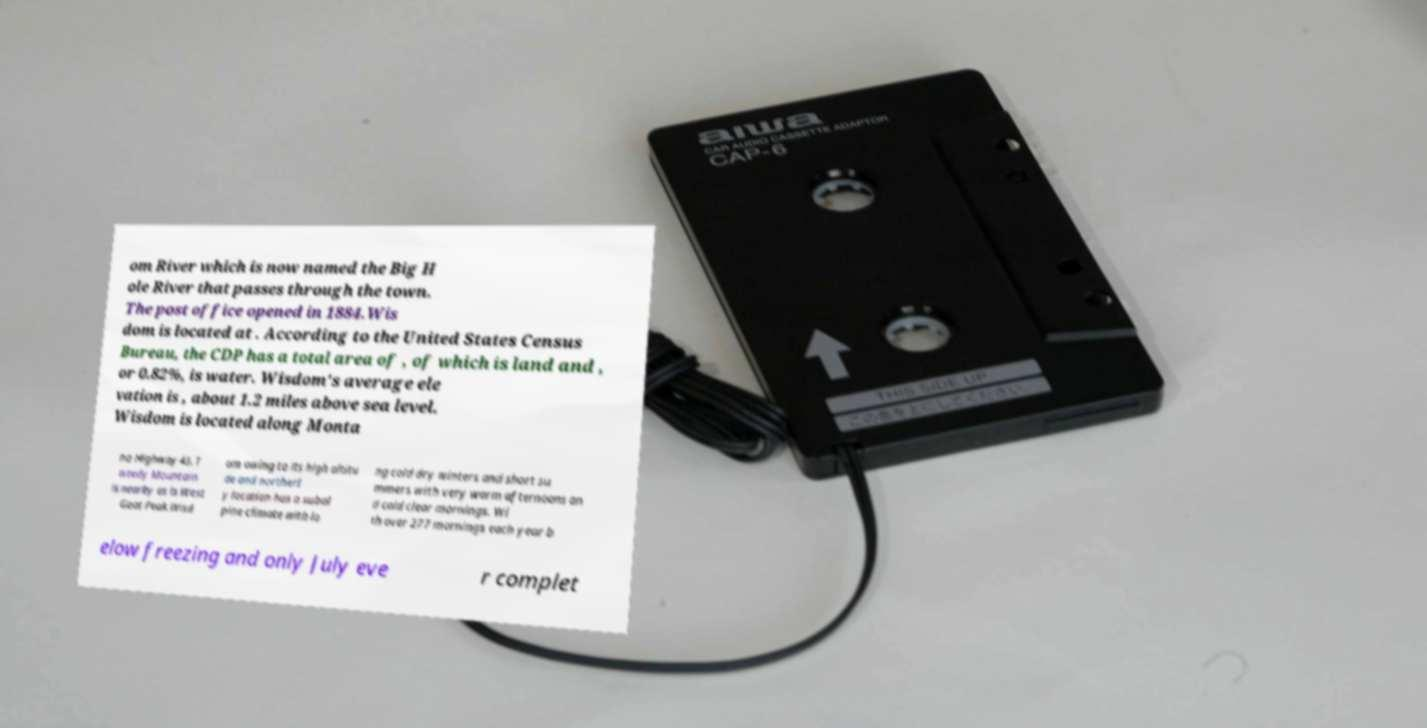Could you extract and type out the text from this image? om River which is now named the Big H ole River that passes through the town. The post office opened in 1884.Wis dom is located at . According to the United States Census Bureau, the CDP has a total area of , of which is land and , or 0.82%, is water. Wisdom's average ele vation is , about 1.2 miles above sea level. Wisdom is located along Monta na Highway 43. T weedy Mountain is nearby as is West Goat Peak.Wisd om owing to its high altitu de and northerl y location has a subal pine climate with lo ng cold dry winters and short su mmers with very warm afternoons an d cold clear mornings. Wi th over 277 mornings each year b elow freezing and only July eve r complet 